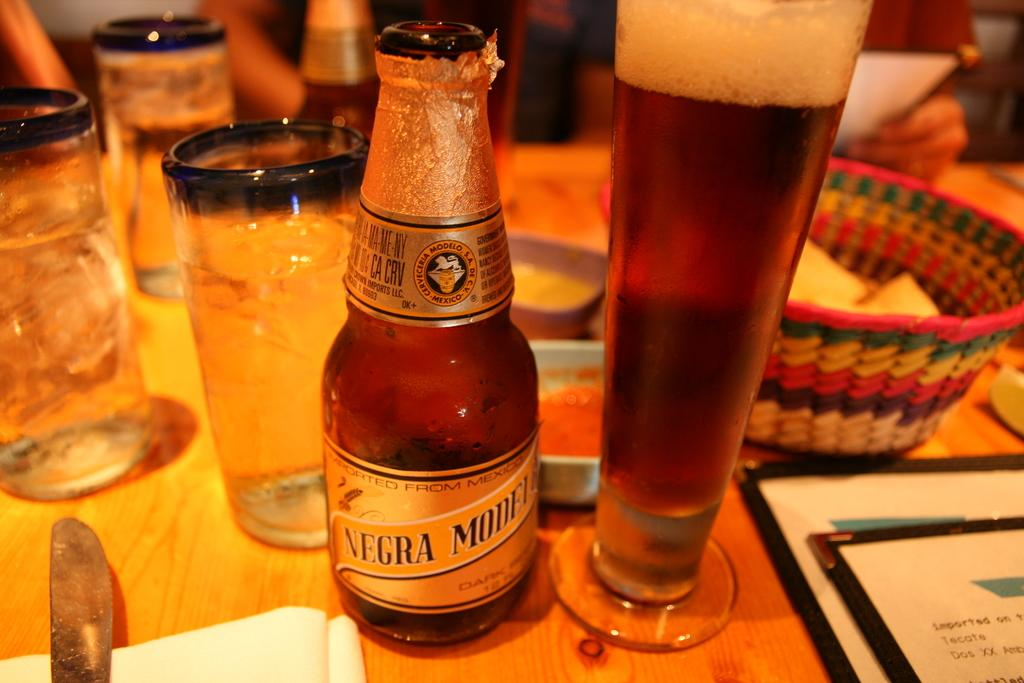<image>
Provide a brief description of the given image. Mexico Imported drink with the label Negra Modelo. 